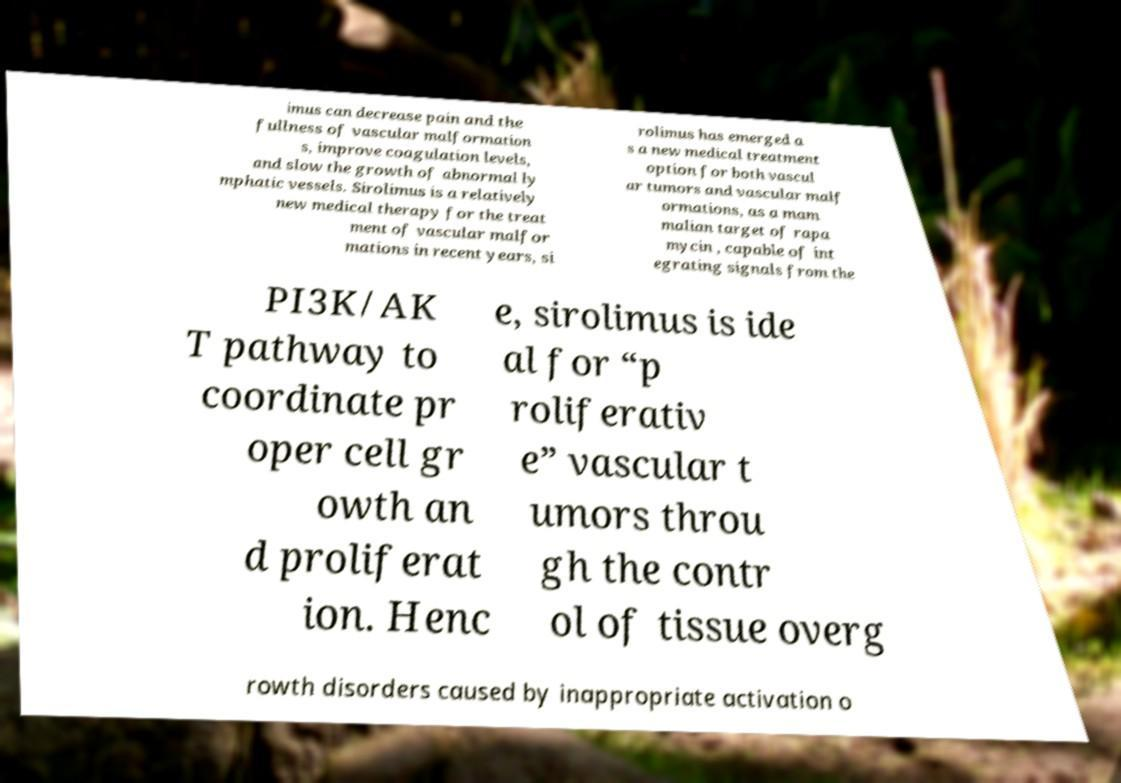Can you accurately transcribe the text from the provided image for me? imus can decrease pain and the fullness of vascular malformation s, improve coagulation levels, and slow the growth of abnormal ly mphatic vessels. Sirolimus is a relatively new medical therapy for the treat ment of vascular malfor mations in recent years, si rolimus has emerged a s a new medical treatment option for both vascul ar tumors and vascular malf ormations, as a mam malian target of rapa mycin , capable of int egrating signals from the PI3K/AK T pathway to coordinate pr oper cell gr owth an d proliferat ion. Henc e, sirolimus is ide al for “p roliferativ e” vascular t umors throu gh the contr ol of tissue overg rowth disorders caused by inappropriate activation o 